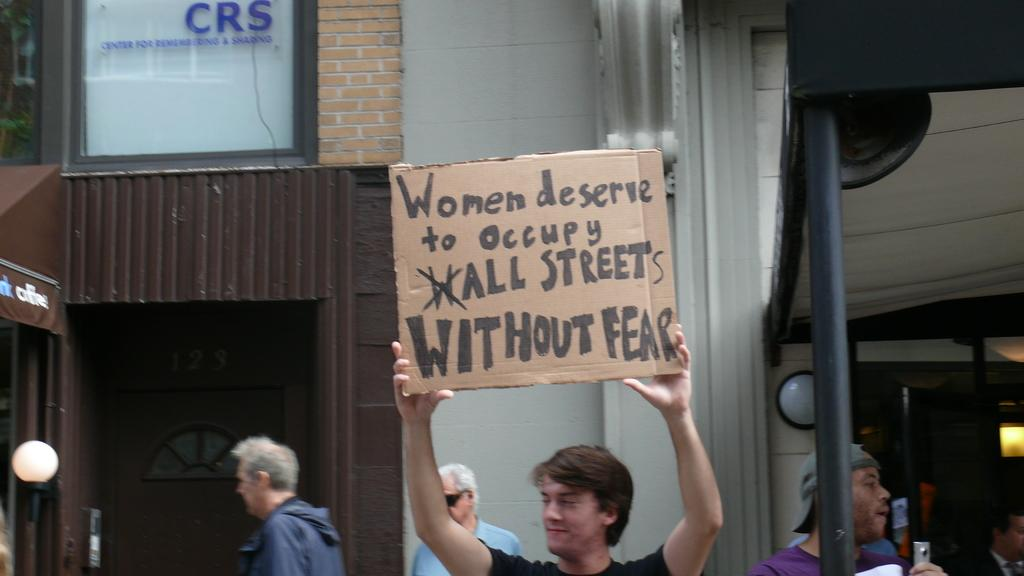What can be seen in the image? There are men standing in the image. What is one of the men holding? One of the men is holding a placard in his hands. What can be seen in the distance behind the men? There are buildings in the background of the image. How many crimes are being committed in the image? There is no indication of any crimes being committed in the image. What type of foot is visible on the placard? There is no foot visible on the placard; it is a placard with text or a message. 